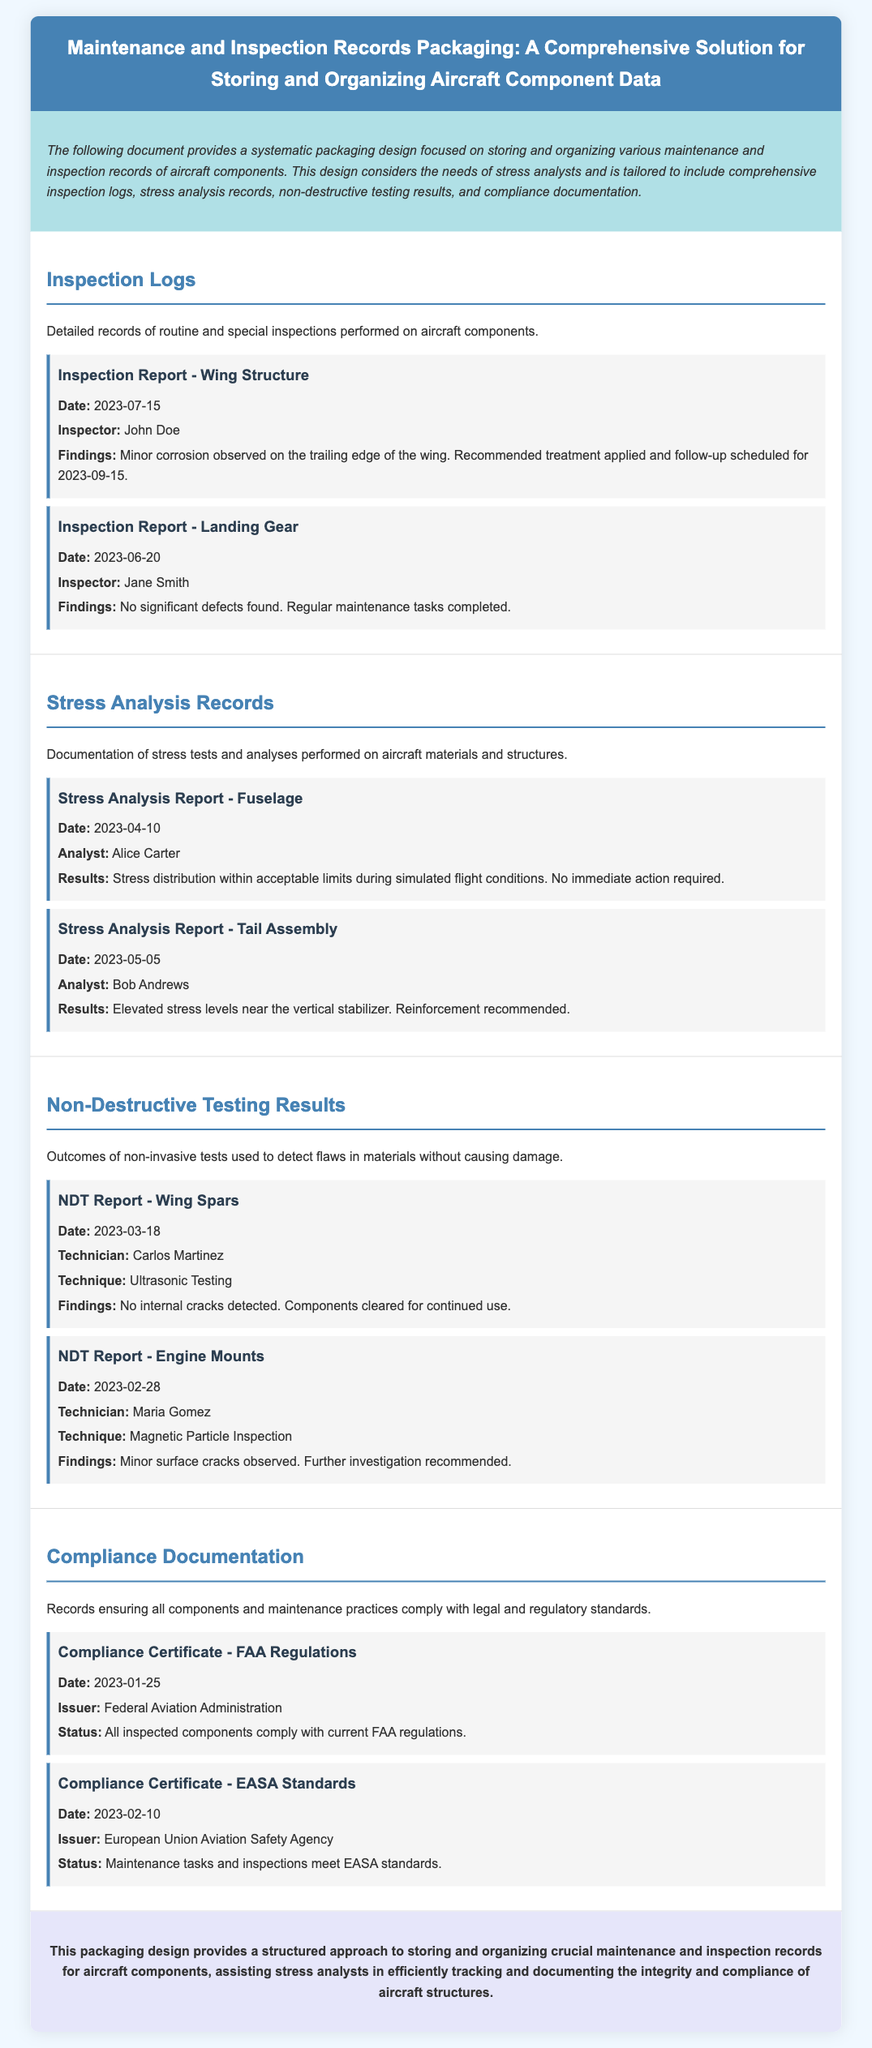What is the title of the document? The title is mentioned in the header of the document, which is "Maintenance and Inspection Records Packaging: A Comprehensive Solution for Storing and Organizing Aircraft Component Data."
Answer: Maintenance and Inspection Records Packaging: A Comprehensive Solution for Storing and Organizing Aircraft Component Data Who performed the inspection on the wing structure? The inspector's name is provided in the inspection log for the wing structure report.
Answer: John Doe What date was the NDT report for wing spars conducted? The date of the NDT report is specified in the record section for wing spars.
Answer: 2023-03-18 What were the findings in the stress analysis report for the tail assembly? The results of the stress analysis report for the tail assembly highlight specific issues in the report section.
Answer: Elevated stress levels near the vertical stabilizer Which regulatory agency issued the compliance certificate for FAA regulations? The issuer of the compliance certificate is mentioned in the compliance documentation section.
Answer: Federal Aviation Administration What technique was used in the NDT report for engine mounts? The technique used is listed in the NDT report for engine mounts.
Answer: Magnetic Particle Inspection How many inspection logs are detailed in the document? The document provides details on the number of inspection logs included, which can be counted.
Answer: 2 What is the status of the compliance with EASA standards? The status for compliance with EASA standards is stated in the compliance documentation section.
Answer: Maintenance tasks and inspections meet EASA standards 